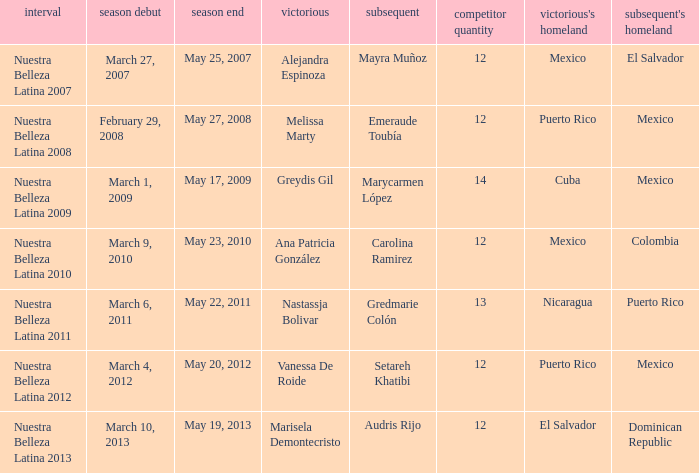What season had more than 12 contestants in which greydis gil won? Nuestra Belleza Latina 2009. 